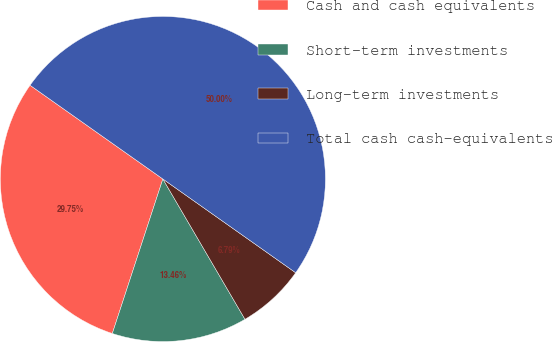Convert chart. <chart><loc_0><loc_0><loc_500><loc_500><pie_chart><fcel>Cash and cash equivalents<fcel>Short-term investments<fcel>Long-term investments<fcel>Total cash cash-equivalents<nl><fcel>29.75%<fcel>13.46%<fcel>6.79%<fcel>50.0%<nl></chart> 